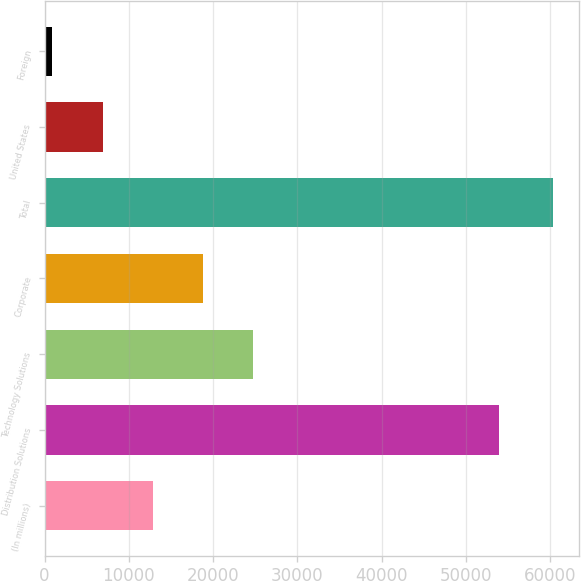<chart> <loc_0><loc_0><loc_500><loc_500><bar_chart><fcel>(In millions)<fcel>Distribution Solutions<fcel>Technology Solutions<fcel>Corporate<fcel>Total<fcel>United States<fcel>Foreign<nl><fcel>12824.2<fcel>53915<fcel>24713.4<fcel>18768.8<fcel>60381<fcel>6879.6<fcel>935<nl></chart> 